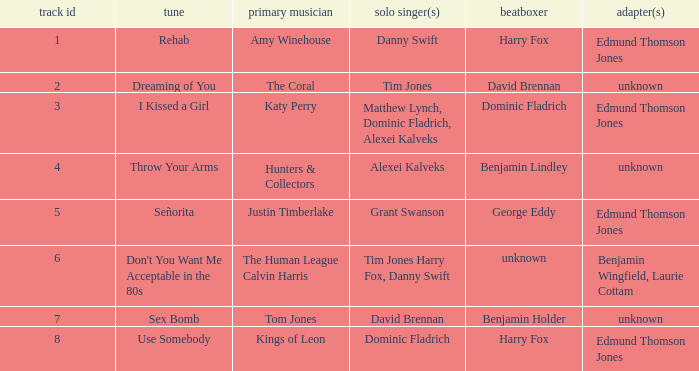Who is the original artist of "Use Somebody"? Kings of Leon. 